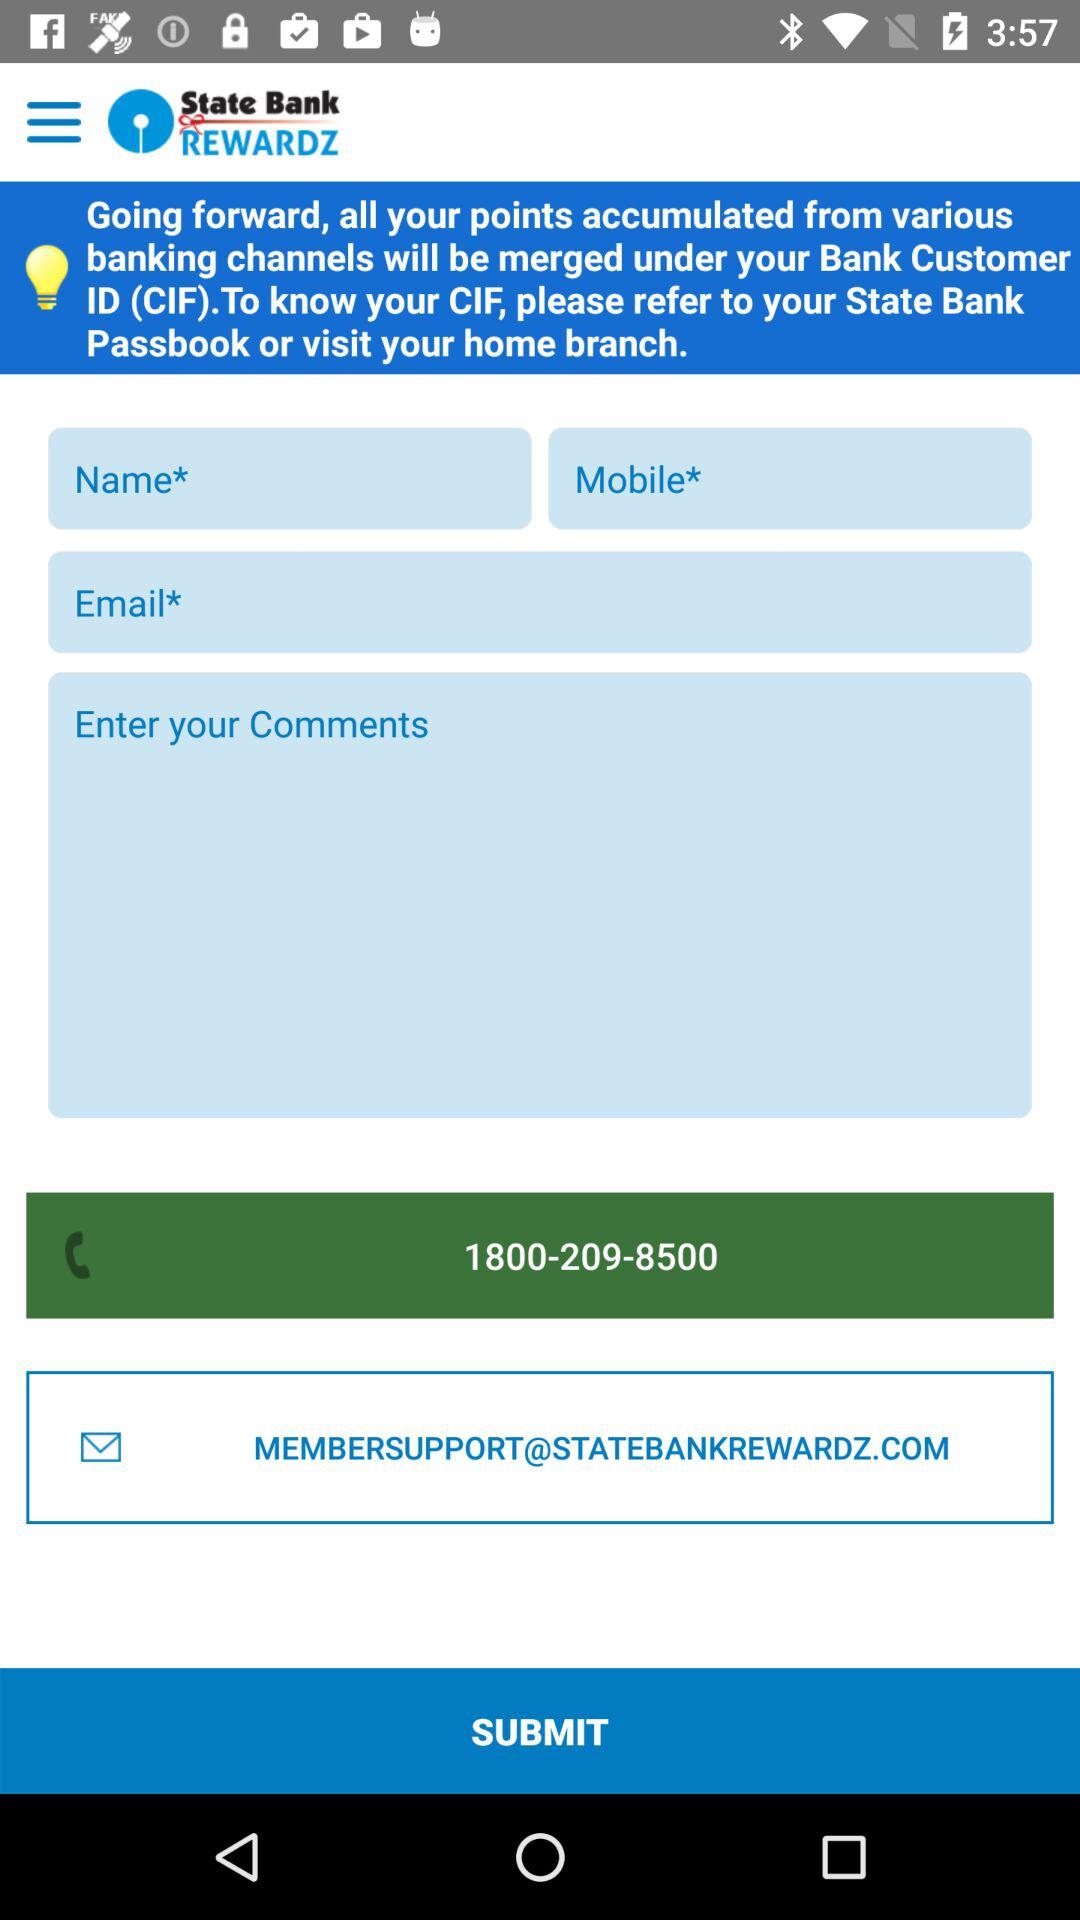What is the toll-free number for "State Bank REWARDZ"? The toll-free number is 1800-209-8500. 